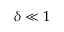<formula> <loc_0><loc_0><loc_500><loc_500>\delta \ll 1</formula> 